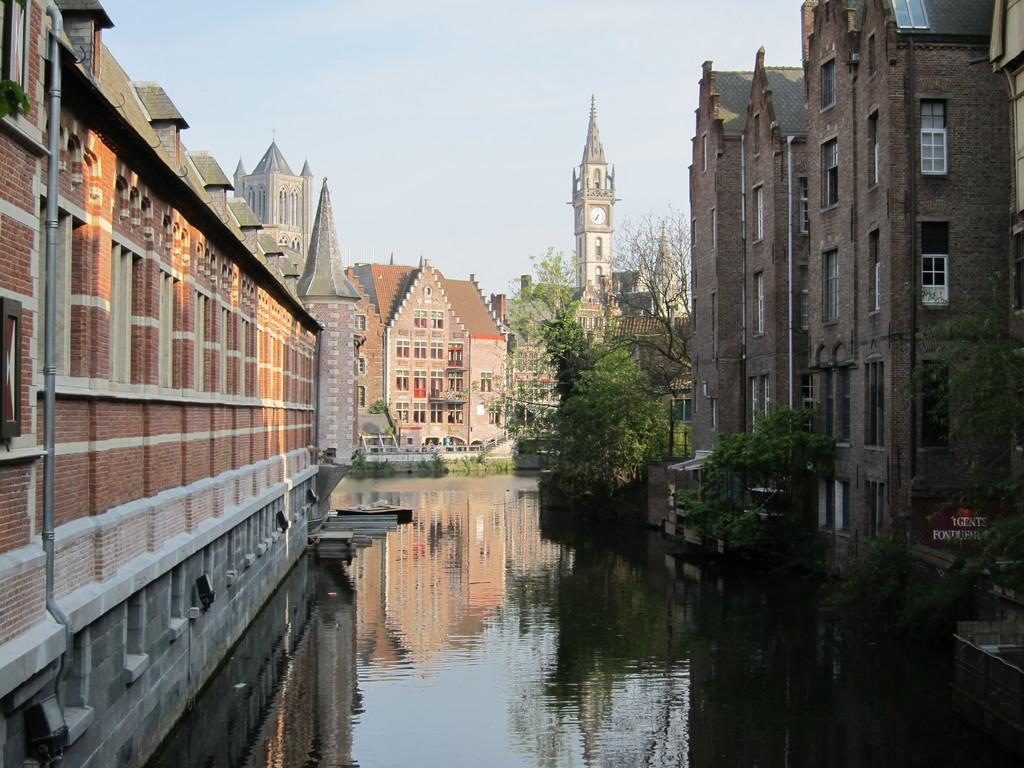What is the primary element in the image? There is water in the image. What can be seen near the water? There are many trees near the water. What type of structures are visible in the image? There are buildings visible in the image. What is located to the right of the water? There is a board to the right of the water. What is visible in the background of the image? The sky is visible in the background of the image. How many feet are visible in the image? There are no feet visible in the image. Who is the governor in the image? There is no governor present in the image. 